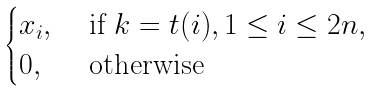<formula> <loc_0><loc_0><loc_500><loc_500>\begin{cases} x _ { i } , & \text { if } k = t ( i ) , 1 \leq i \leq 2 n , \\ 0 , & \text { otherwise} \end{cases}</formula> 